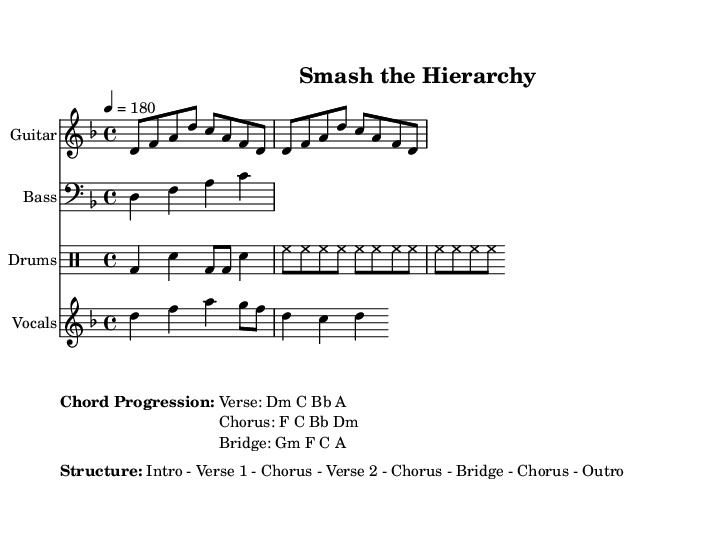What is the key signature of this piece? The key signature indicated by the global section is D minor, which has one flat (B flat).
Answer: D minor What is the time signature of this sheet music? The time signature shown in the global section is 4/4, which means there are four beats in each measure and the quarter note receives one beat.
Answer: 4/4 What is the tempo marking for this composition? The tempo indicated in the global section is quarter note equals 180, meaning the music should be played at a fast pace.
Answer: 180 What is the chord progression for the verse? The chord progression for the verse is listed as D minor, C, B flat, and A in the markup section.
Answer: Dm C Bb A How many times is the drum pattern repeated? The drum pattern is repeated three times, as indicated by the repeat unfold notation placed in the drum section of the score.
Answer: 3 Which lyric accompanies the vocal melody? The lyrics provided alongside the vocal melody state, "Break the chains, tear down the walls, Equality for one and all," reflecting themes of social justice.
Answer: "Break the chains, tear down the walls, Equality for one and all." What is the overall structure of the song? The structure is described in the markup section as "Intro - Verse 1 - Chorus - Verse 2 - Chorus - Bridge - Chorus - Outro," indicating how the song is organized.
Answer: Intro - Verse 1 - Chorus - Verse 2 - Chorus - Bridge - Chorus - Outro 